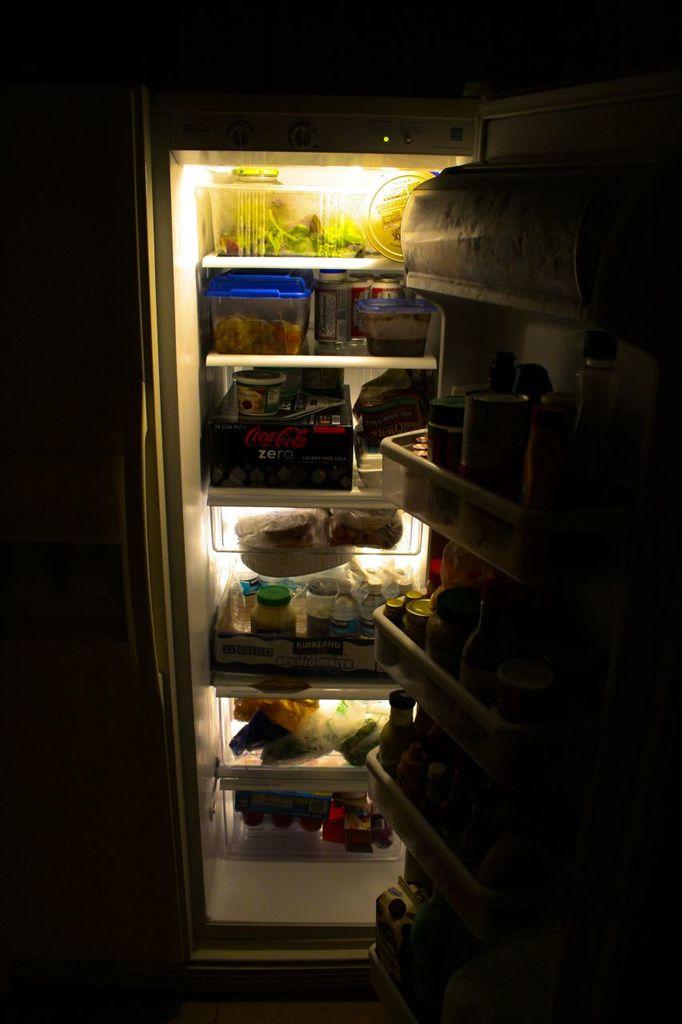What is one brand of food in there?
Give a very brief answer. Coca-cola. 